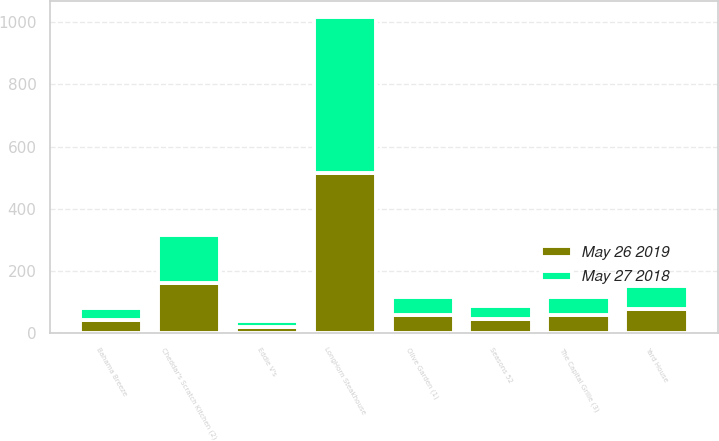Convert chart to OTSL. <chart><loc_0><loc_0><loc_500><loc_500><stacked_bar_chart><ecel><fcel>Olive Garden (1)<fcel>LongHorn Steakhouse<fcel>Cheddar's Scratch Kitchen (2)<fcel>Yard House<fcel>The Capital Grille (3)<fcel>Seasons 52<fcel>Bahama Breeze<fcel>Eddie V's<nl><fcel>May 26 2019<fcel>58<fcel>514<fcel>161<fcel>79<fcel>58<fcel>44<fcel>42<fcel>21<nl><fcel>May 27 2018<fcel>58<fcel>504<fcel>156<fcel>72<fcel>58<fcel>42<fcel>39<fcel>19<nl></chart> 